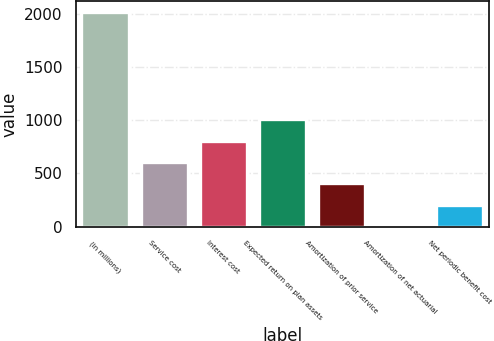<chart> <loc_0><loc_0><loc_500><loc_500><bar_chart><fcel>(in millions)<fcel>Service cost<fcel>Interest cost<fcel>Expected return on plan assets<fcel>Amortization of prior service<fcel>Amortization of net actuarial<fcel>Net periodic benefit cost<nl><fcel>2015<fcel>607.23<fcel>808.34<fcel>1009.45<fcel>406.12<fcel>3.9<fcel>205.01<nl></chart> 